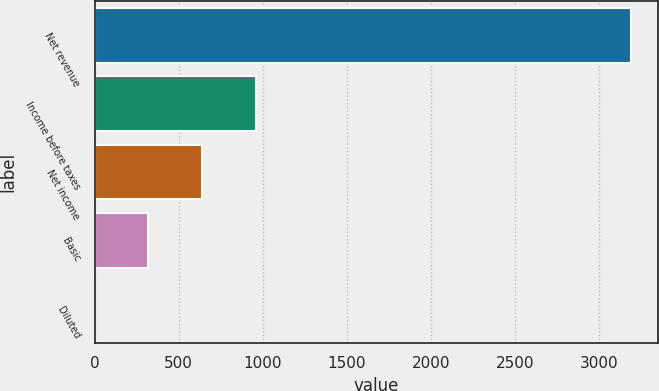<chart> <loc_0><loc_0><loc_500><loc_500><bar_chart><fcel>Net revenue<fcel>Income before taxes<fcel>Net income<fcel>Basic<fcel>Diluted<nl><fcel>3189<fcel>957.08<fcel>638.24<fcel>319.4<fcel>0.56<nl></chart> 